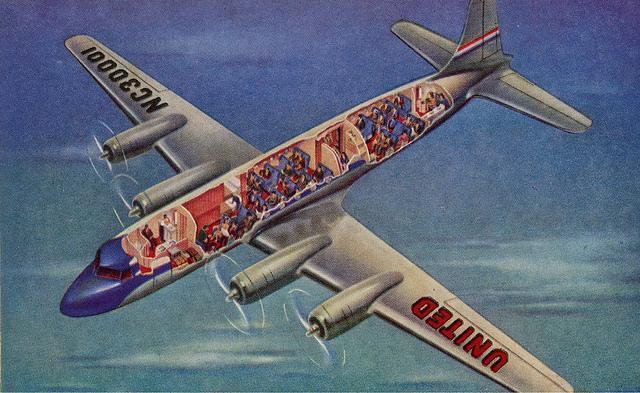How many white cars are there?
Give a very brief answer. 0. 